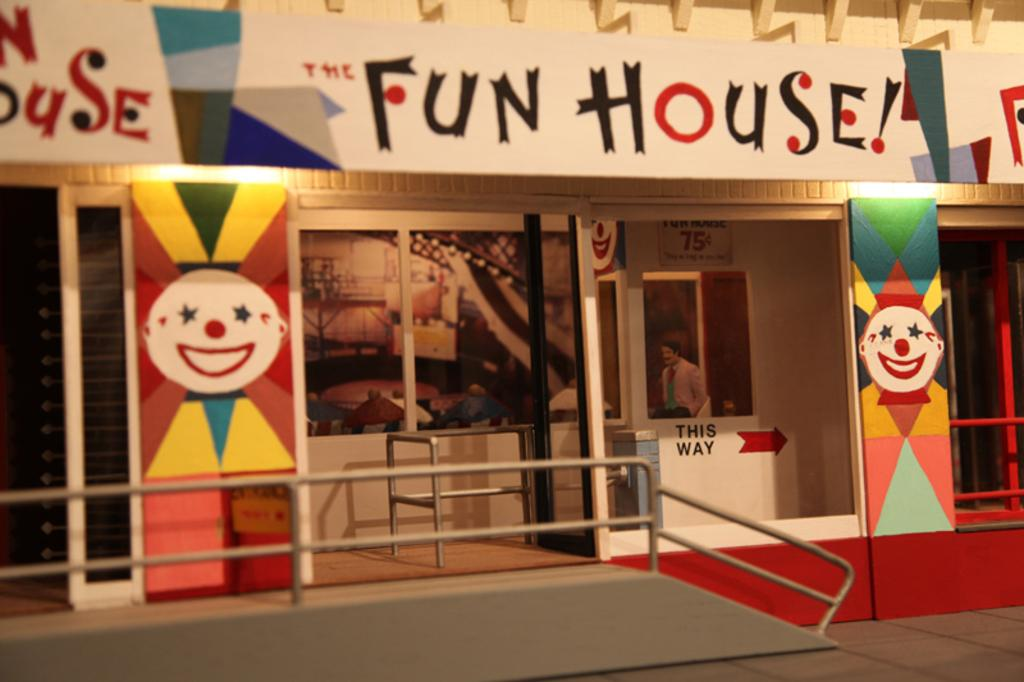<image>
Write a terse but informative summary of the picture. An empty ride called The Fun House with a ramp leading to the entrance. 